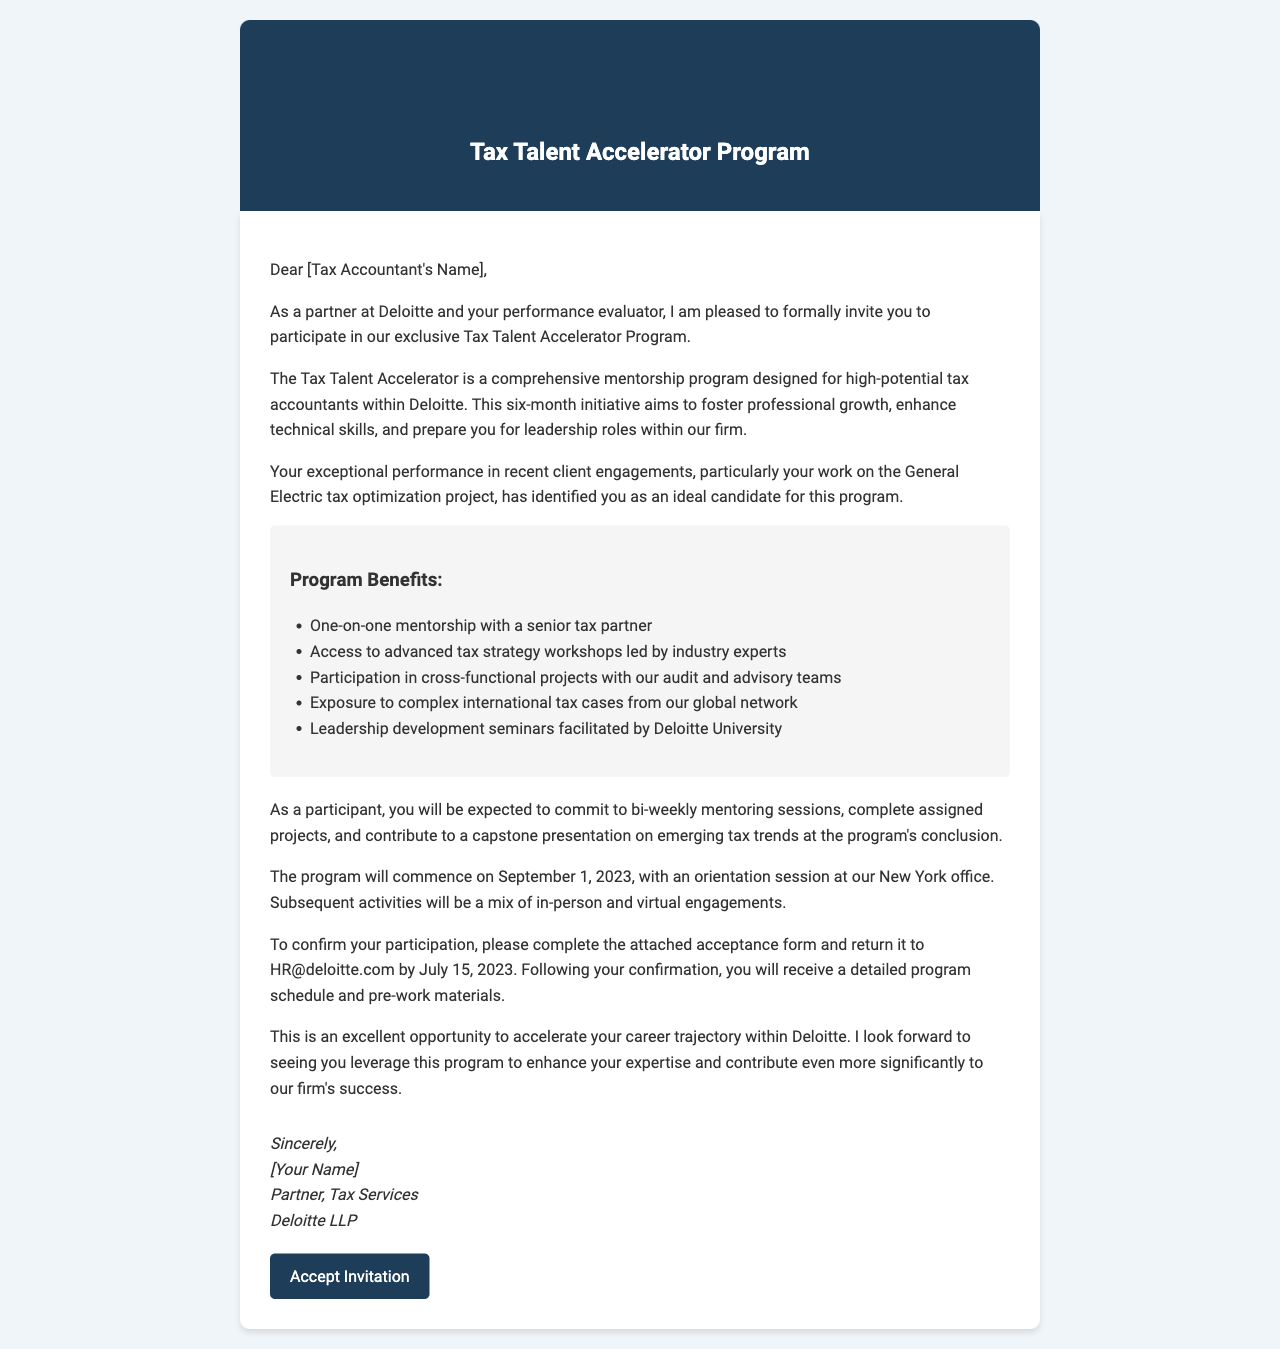What is the name of the program? The program is designed specifically for high-potential tax accountants and is named in the document.
Answer: Tax Talent Accelerator Program Who is the sender of the letter? The closure of the letter provides the name and position of the sender.
Answer: [Your Name] When does the program start? The document states the commencement date of the program clearly.
Answer: September 1, 2023 What is the main goal of the Tax Talent Accelerator Program? The document mentions the primary aim of the initiative for the participants.
Answer: Foster professional growth How many months does the program last? The duration of the program is specified in the description.
Answer: Six months What type of projects will participants engage in? The description details the nature of projects participants will be involved in during the program.
Answer: Cross-functional projects What is required from participants regarding mentoring sessions? The expectations section outlines the commitment needed for mentoring.
Answer: Commit to bi-weekly mentoring sessions What is the deadline for confirming participation? The next steps section indicates the last date for confirmation.
Answer: July 15, 2023 Which office will host the orientation session? The timeline and location section specifies where the orientation will be held.
Answer: New York office 